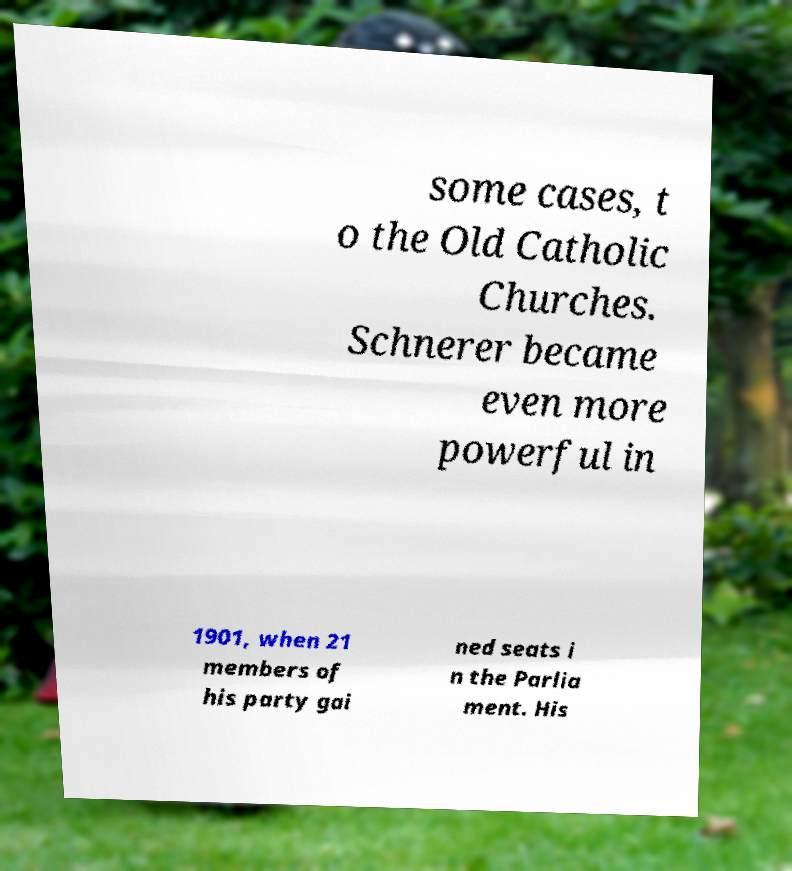Can you accurately transcribe the text from the provided image for me? some cases, t o the Old Catholic Churches. Schnerer became even more powerful in 1901, when 21 members of his party gai ned seats i n the Parlia ment. His 